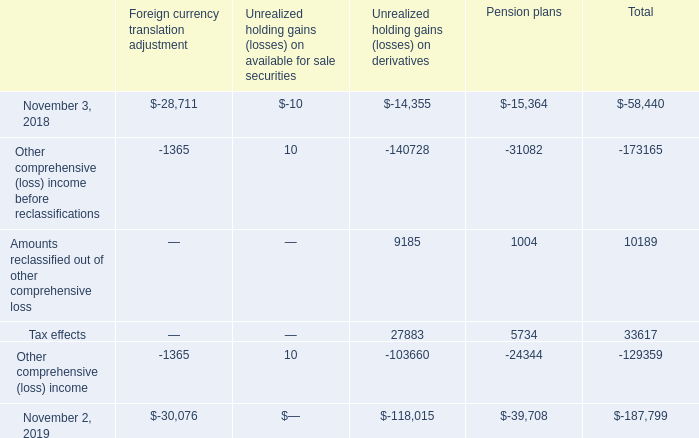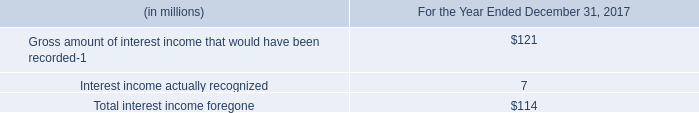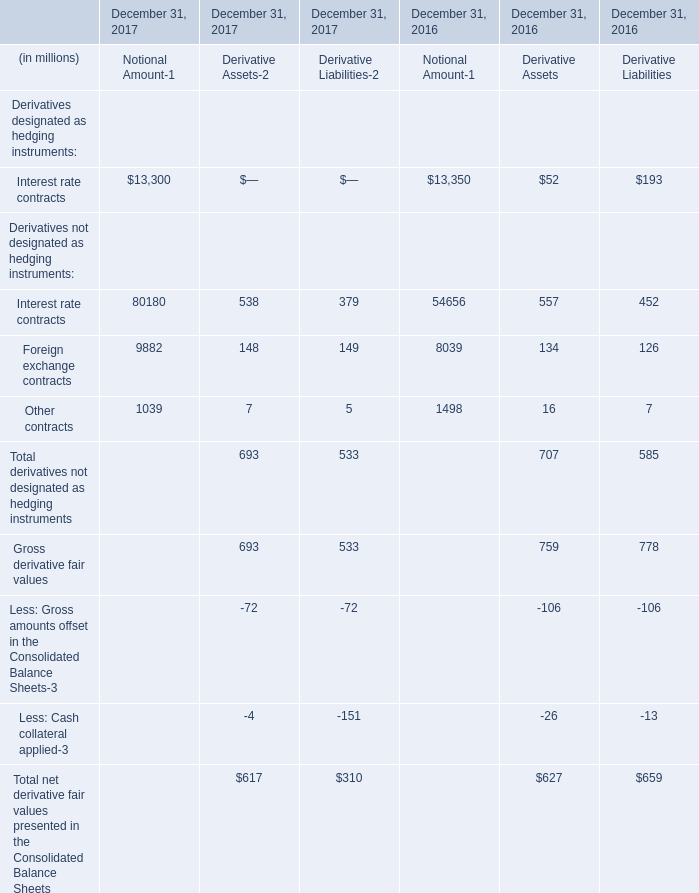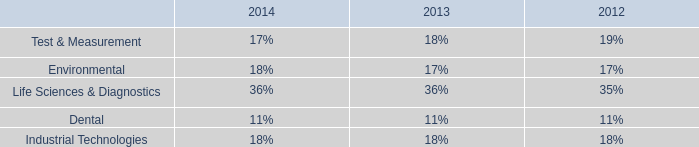what is the net change in the liability balance from 2018 to 2019? 
Computations: (227.0 - 144.9)
Answer: 82.1. 